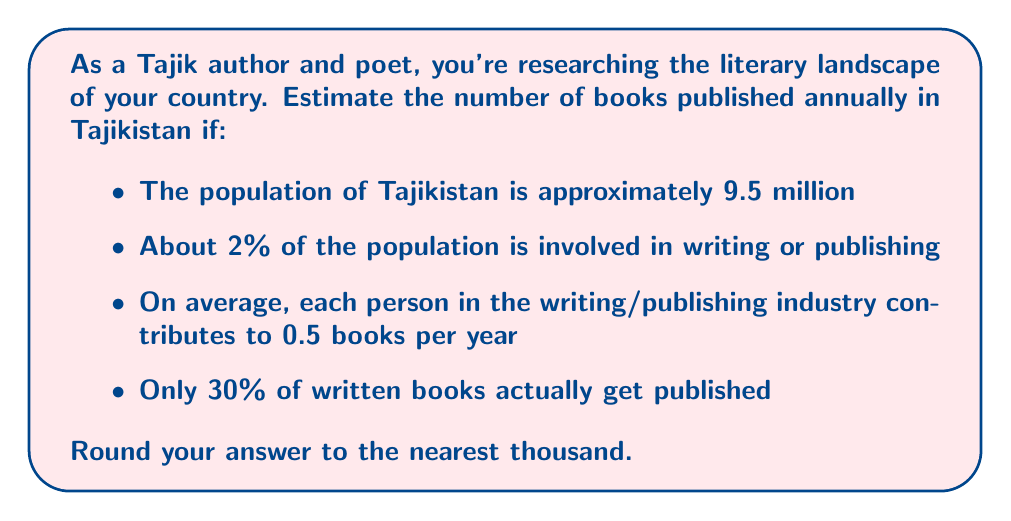Teach me how to tackle this problem. Let's approach this step-by-step:

1. Calculate the number of people involved in writing or publishing:
   $$9,500,000 \times 0.02 = 190,000$$

2. Estimate the total number of books written per year:
   $$190,000 \times 0.5 = 95,000$$

3. Calculate the number of books that actually get published:
   $$95,000 \times 0.30 = 28,500$$

4. Round to the nearest thousand:
   $$28,500 \approx 29,000$$

Therefore, we estimate that approximately 29,000 books are published in Tajikistan annually.
Answer: 29,000 books 